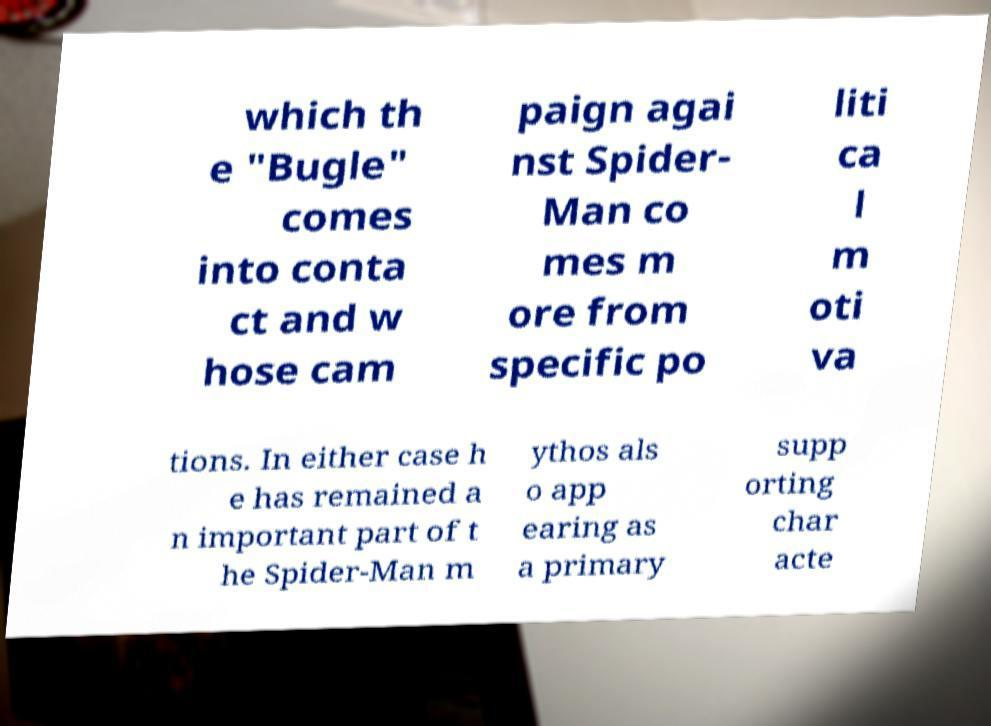Can you accurately transcribe the text from the provided image for me? which th e "Bugle" comes into conta ct and w hose cam paign agai nst Spider- Man co mes m ore from specific po liti ca l m oti va tions. In either case h e has remained a n important part of t he Spider-Man m ythos als o app earing as a primary supp orting char acte 